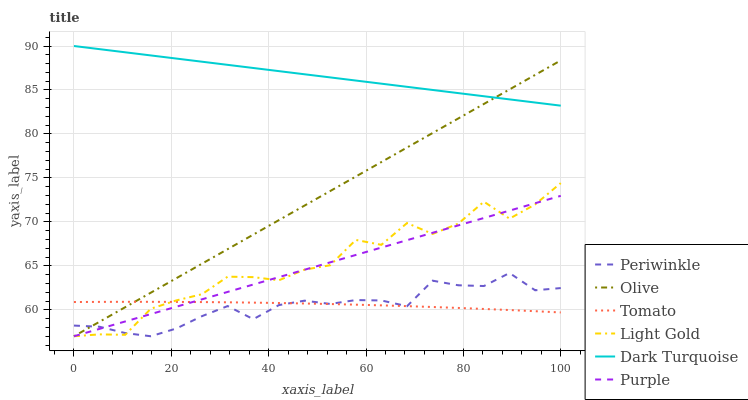Does Periwinkle have the minimum area under the curve?
Answer yes or no. Yes. Does Dark Turquoise have the maximum area under the curve?
Answer yes or no. Yes. Does Purple have the minimum area under the curve?
Answer yes or no. No. Does Purple have the maximum area under the curve?
Answer yes or no. No. Is Olive the smoothest?
Answer yes or no. Yes. Is Light Gold the roughest?
Answer yes or no. Yes. Is Purple the smoothest?
Answer yes or no. No. Is Purple the roughest?
Answer yes or no. No. Does Purple have the lowest value?
Answer yes or no. Yes. Does Dark Turquoise have the lowest value?
Answer yes or no. No. Does Dark Turquoise have the highest value?
Answer yes or no. Yes. Does Purple have the highest value?
Answer yes or no. No. Is Light Gold less than Dark Turquoise?
Answer yes or no. Yes. Is Dark Turquoise greater than Periwinkle?
Answer yes or no. Yes. Does Tomato intersect Purple?
Answer yes or no. Yes. Is Tomato less than Purple?
Answer yes or no. No. Is Tomato greater than Purple?
Answer yes or no. No. Does Light Gold intersect Dark Turquoise?
Answer yes or no. No. 